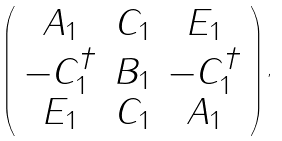Convert formula to latex. <formula><loc_0><loc_0><loc_500><loc_500>\left ( \begin{array} { c c c } A _ { 1 } & C _ { 1 } & E _ { 1 } \\ - C _ { 1 } ^ { \dagger } & B _ { 1 } & - C _ { 1 } ^ { \dagger } \\ E _ { 1 } & C _ { 1 } & A _ { 1 } \end{array} \right ) ,</formula> 